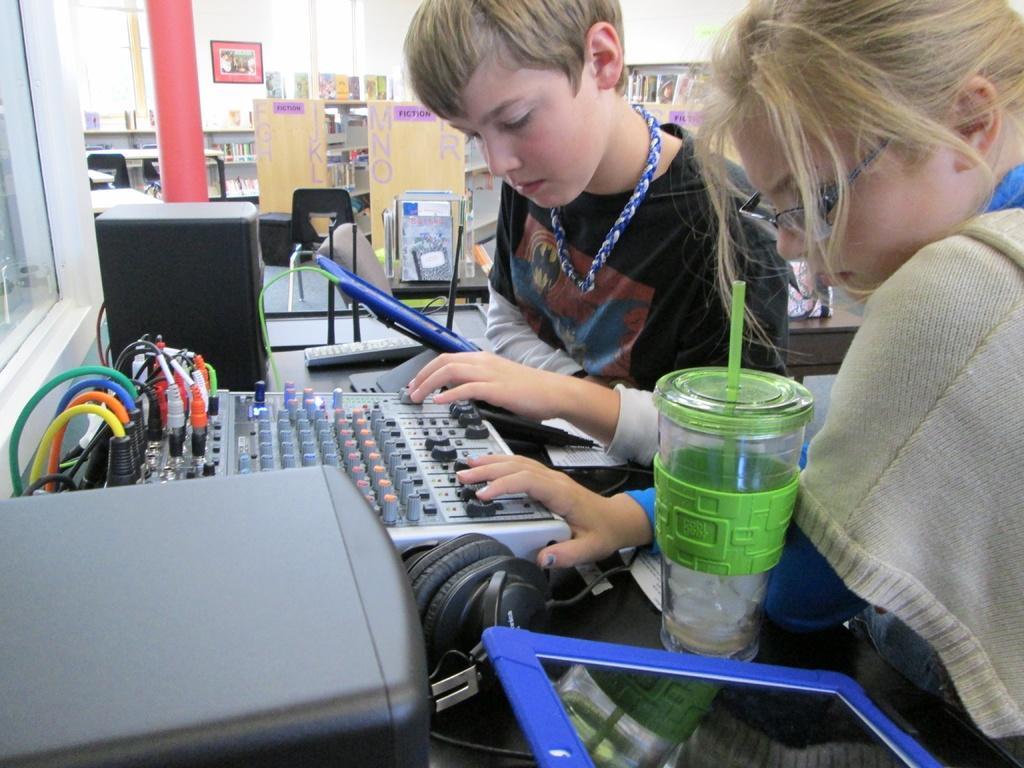How would you summarize this image in a sentence or two? In this picture we can see two persons sitting in front of a table, there is a audio controller, a speaker, headphones, a glass and a remote present on the table, in the background we can see a wall, there is a photo frame on the wall, we can see a chair here, there are some books on the racks. 